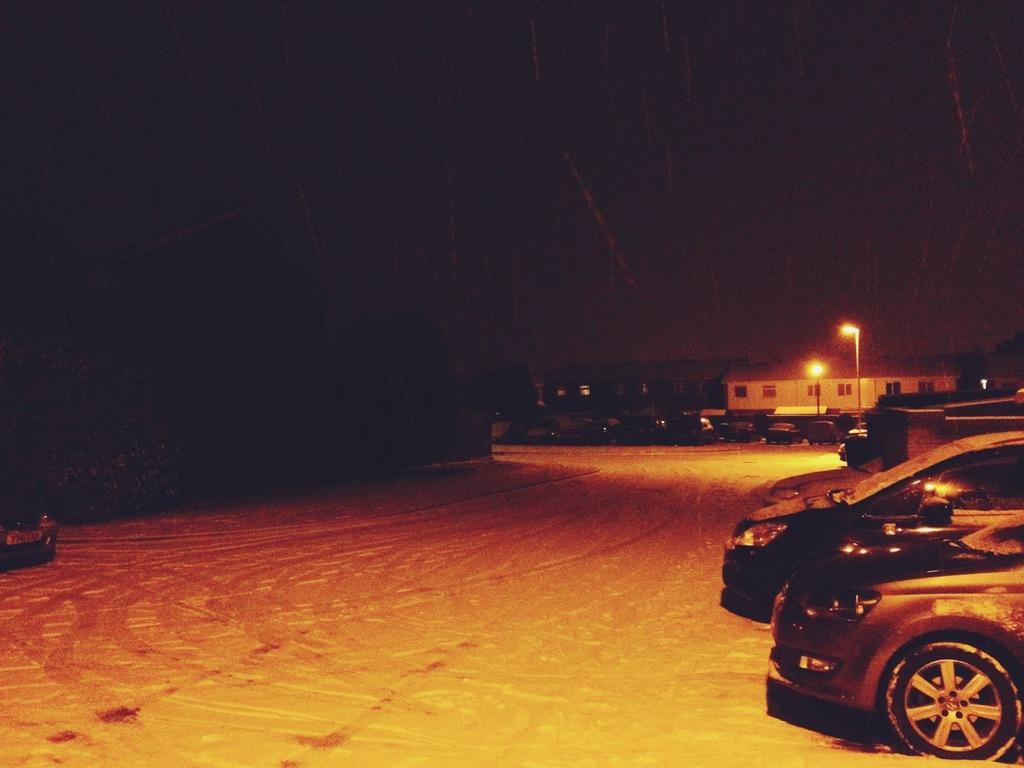Could you give a brief overview of what you see in this image? In the image there is a road and on the right side there are vehicles, in the background there are two street lights and a house. 